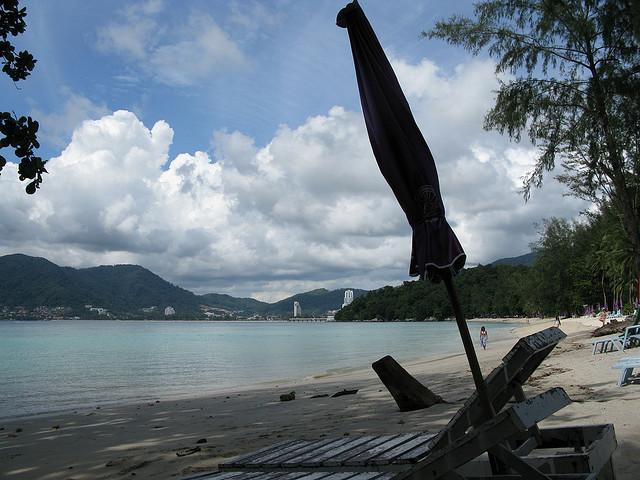Is the chaise lounge in the foreground more likely soft or firm?
Give a very brief answer. Firm. What type of environment setting is this?
Answer briefly. Beach. Is there an umbrella in the picture?
Short answer required. Yes. 